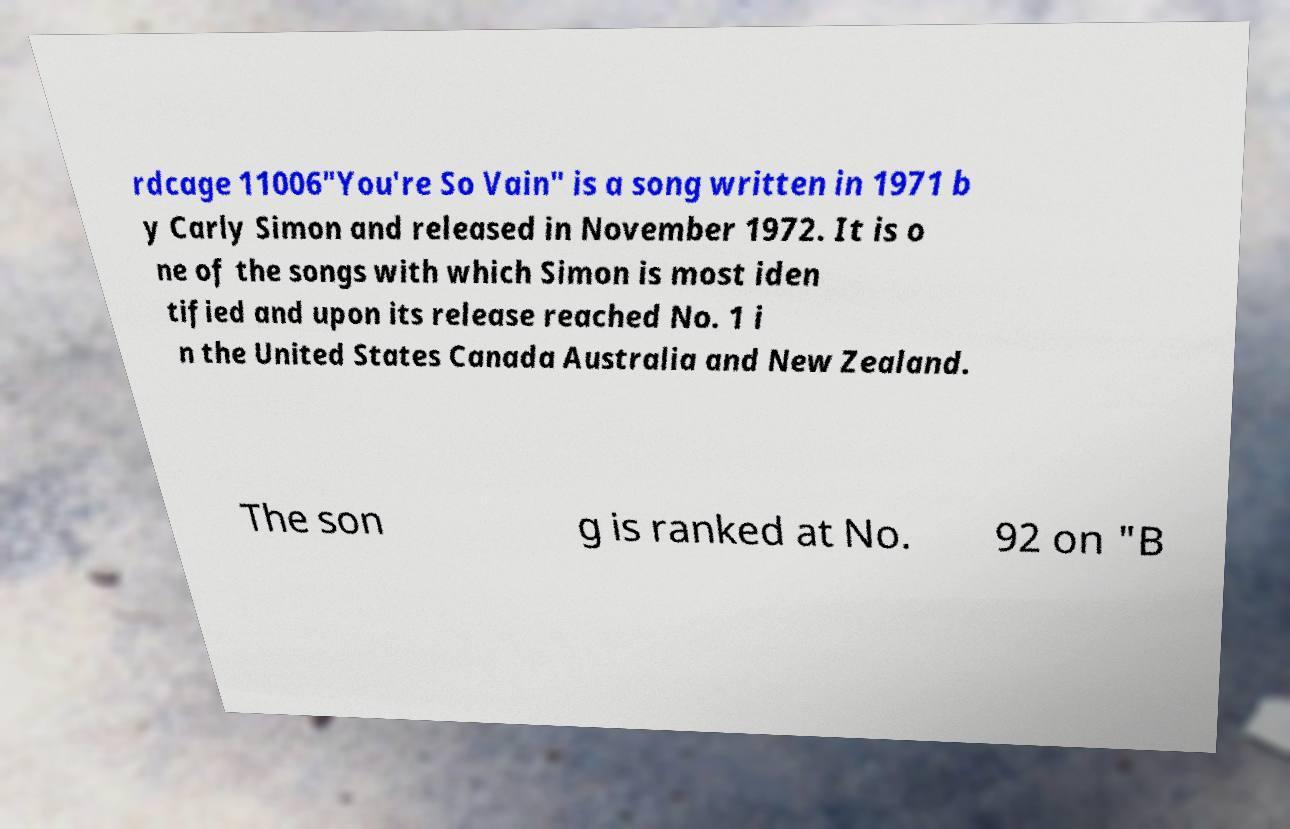There's text embedded in this image that I need extracted. Can you transcribe it verbatim? rdcage 11006"You're So Vain" is a song written in 1971 b y Carly Simon and released in November 1972. It is o ne of the songs with which Simon is most iden tified and upon its release reached No. 1 i n the United States Canada Australia and New Zealand. The son g is ranked at No. 92 on "B 